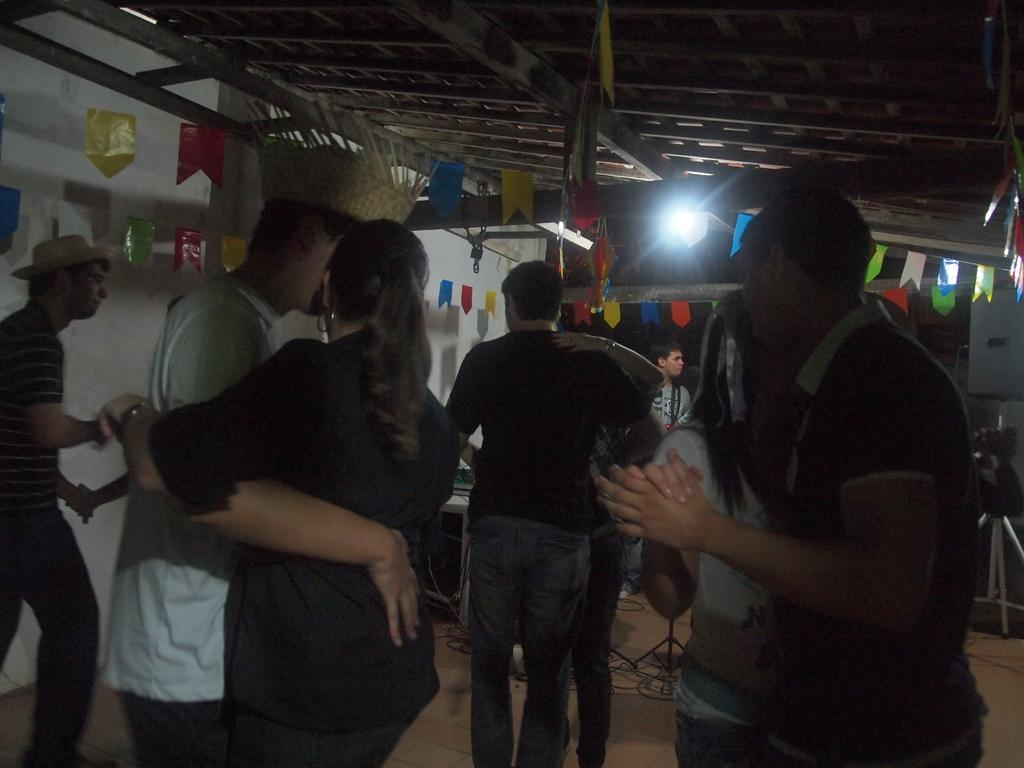What are the people in the image doing? The people in the image are on the floor. What can be seen in the background of the image? There is a wall, flags, and a light in the background of the image. What type of crib is visible in the image? There is no crib present in the image. What attraction can be seen in the background of the image? There is no specific attraction mentioned in the image; only a wall, flags, and a light are visible in the background. 